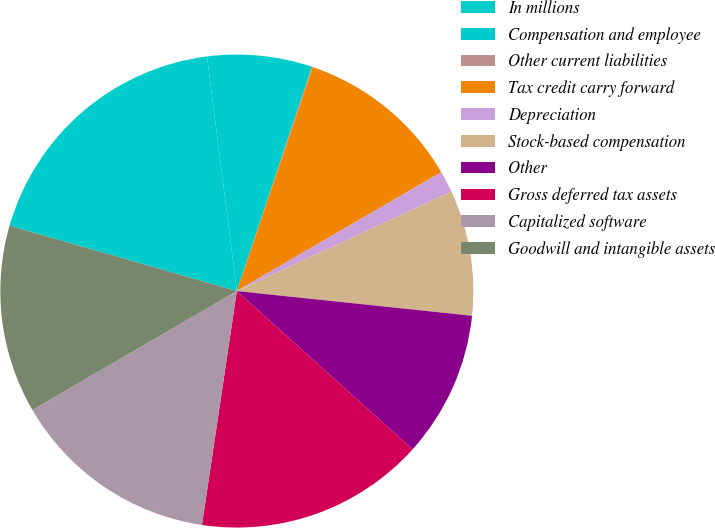Convert chart. <chart><loc_0><loc_0><loc_500><loc_500><pie_chart><fcel>In millions<fcel>Compensation and employee<fcel>Other current liabilities<fcel>Tax credit carry forward<fcel>Depreciation<fcel>Stock-based compensation<fcel>Other<fcel>Gross deferred tax assets<fcel>Capitalized software<fcel>Goodwill and intangible assets<nl><fcel>18.53%<fcel>7.16%<fcel>0.05%<fcel>11.42%<fcel>1.47%<fcel>8.58%<fcel>10.0%<fcel>15.69%<fcel>14.26%<fcel>12.84%<nl></chart> 